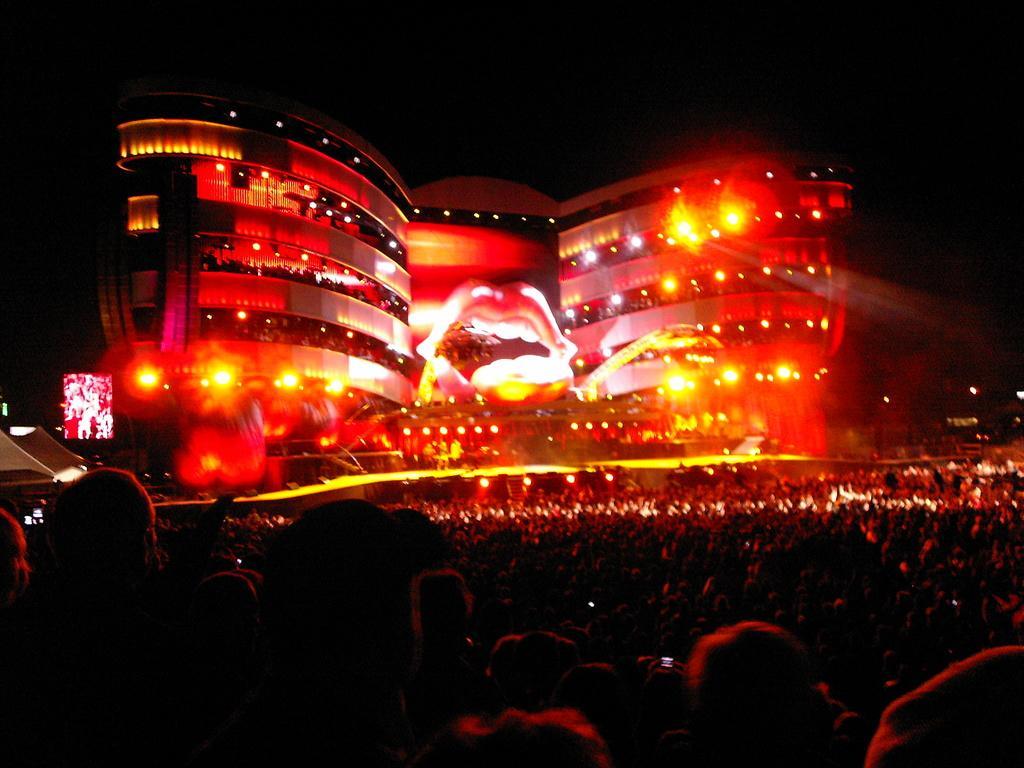In one or two sentences, can you explain what this image depicts? In this image I can see a building. There are group of people, there are lights and there is a screen. And the background is black. 